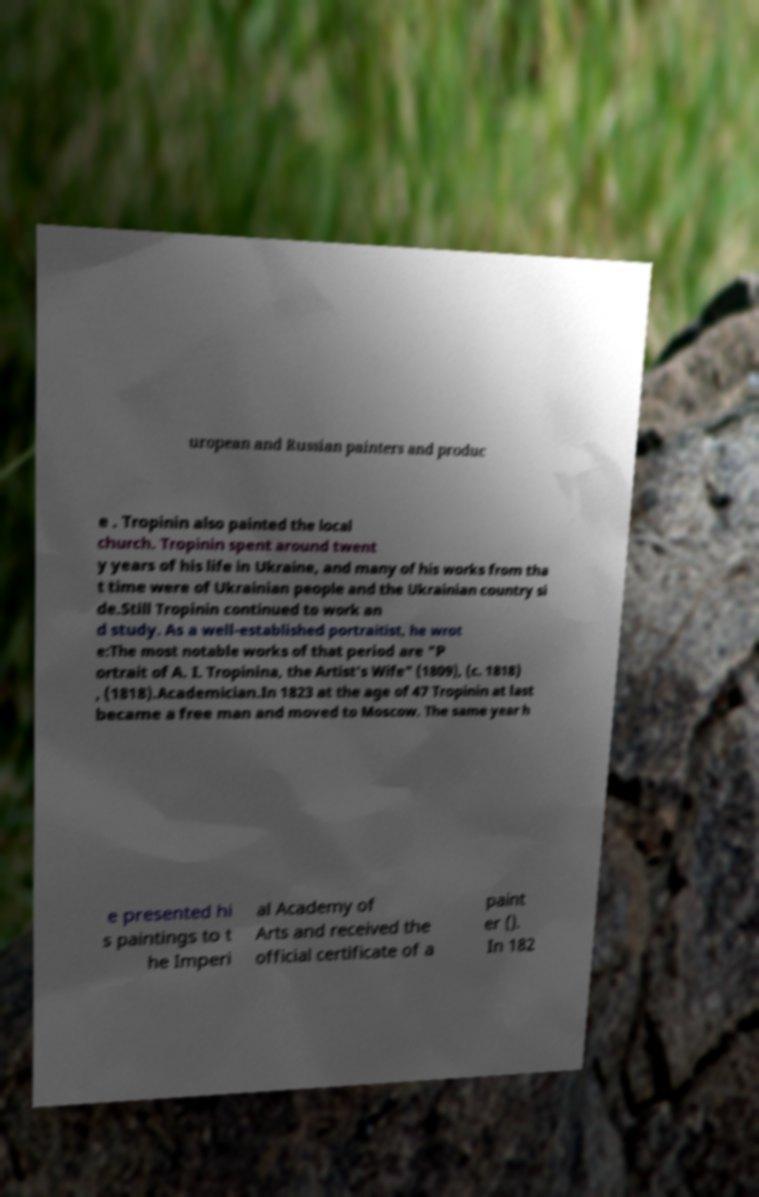For documentation purposes, I need the text within this image transcribed. Could you provide that? uropean and Russian painters and produc e . Tropinin also painted the local church. Tropinin spent around twent y years of his life in Ukraine, and many of his works from tha t time were of Ukrainian people and the Ukrainian country si de.Still Tropinin continued to work an d study. As a well-established portraitist, he wrot e:The most notable works of that period are "P ortrait of A. I. Tropinina, the Artist's Wife" (1809), (c. 1818) , (1818).Academician.In 1823 at the age of 47 Tropinin at last became a free man and moved to Moscow. The same year h e presented hi s paintings to t he Imperi al Academy of Arts and received the official certificate of a paint er (). In 182 